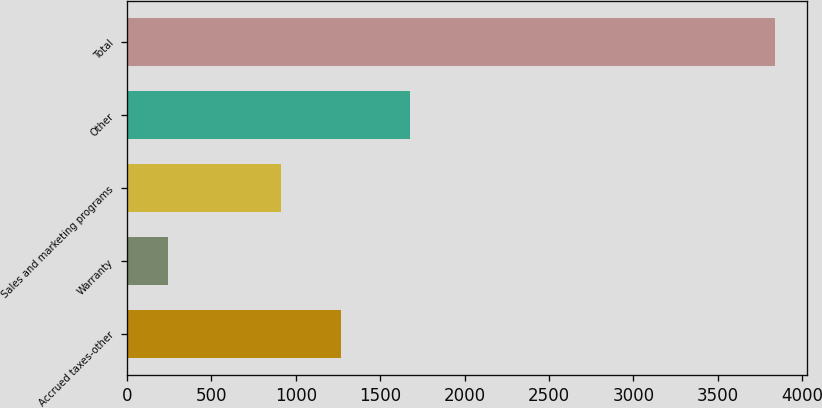Convert chart. <chart><loc_0><loc_0><loc_500><loc_500><bar_chart><fcel>Accrued taxes-other<fcel>Warranty<fcel>Sales and marketing programs<fcel>Other<fcel>Total<nl><fcel>1269.9<fcel>241<fcel>910<fcel>1679<fcel>3840<nl></chart> 